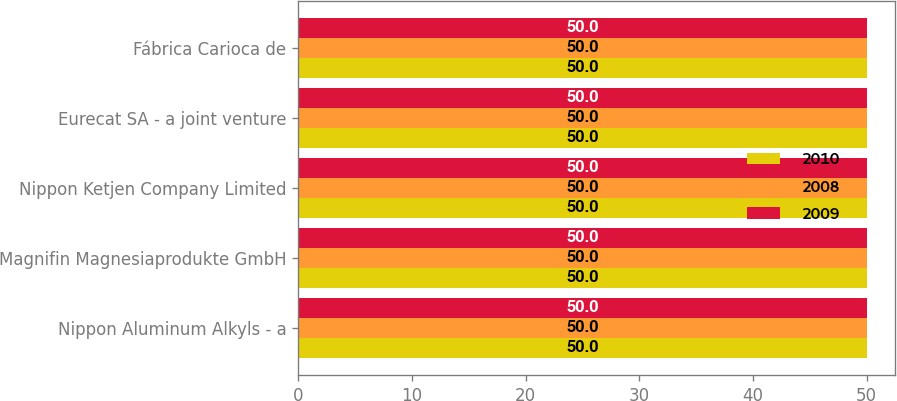Convert chart to OTSL. <chart><loc_0><loc_0><loc_500><loc_500><stacked_bar_chart><ecel><fcel>Nippon Aluminum Alkyls - a<fcel>Magnifin Magnesiaprodukte GmbH<fcel>Nippon Ketjen Company Limited<fcel>Eurecat SA - a joint venture<fcel>Fábrica Carioca de<nl><fcel>2010<fcel>50<fcel>50<fcel>50<fcel>50<fcel>50<nl><fcel>2008<fcel>50<fcel>50<fcel>50<fcel>50<fcel>50<nl><fcel>2009<fcel>50<fcel>50<fcel>50<fcel>50<fcel>50<nl></chart> 